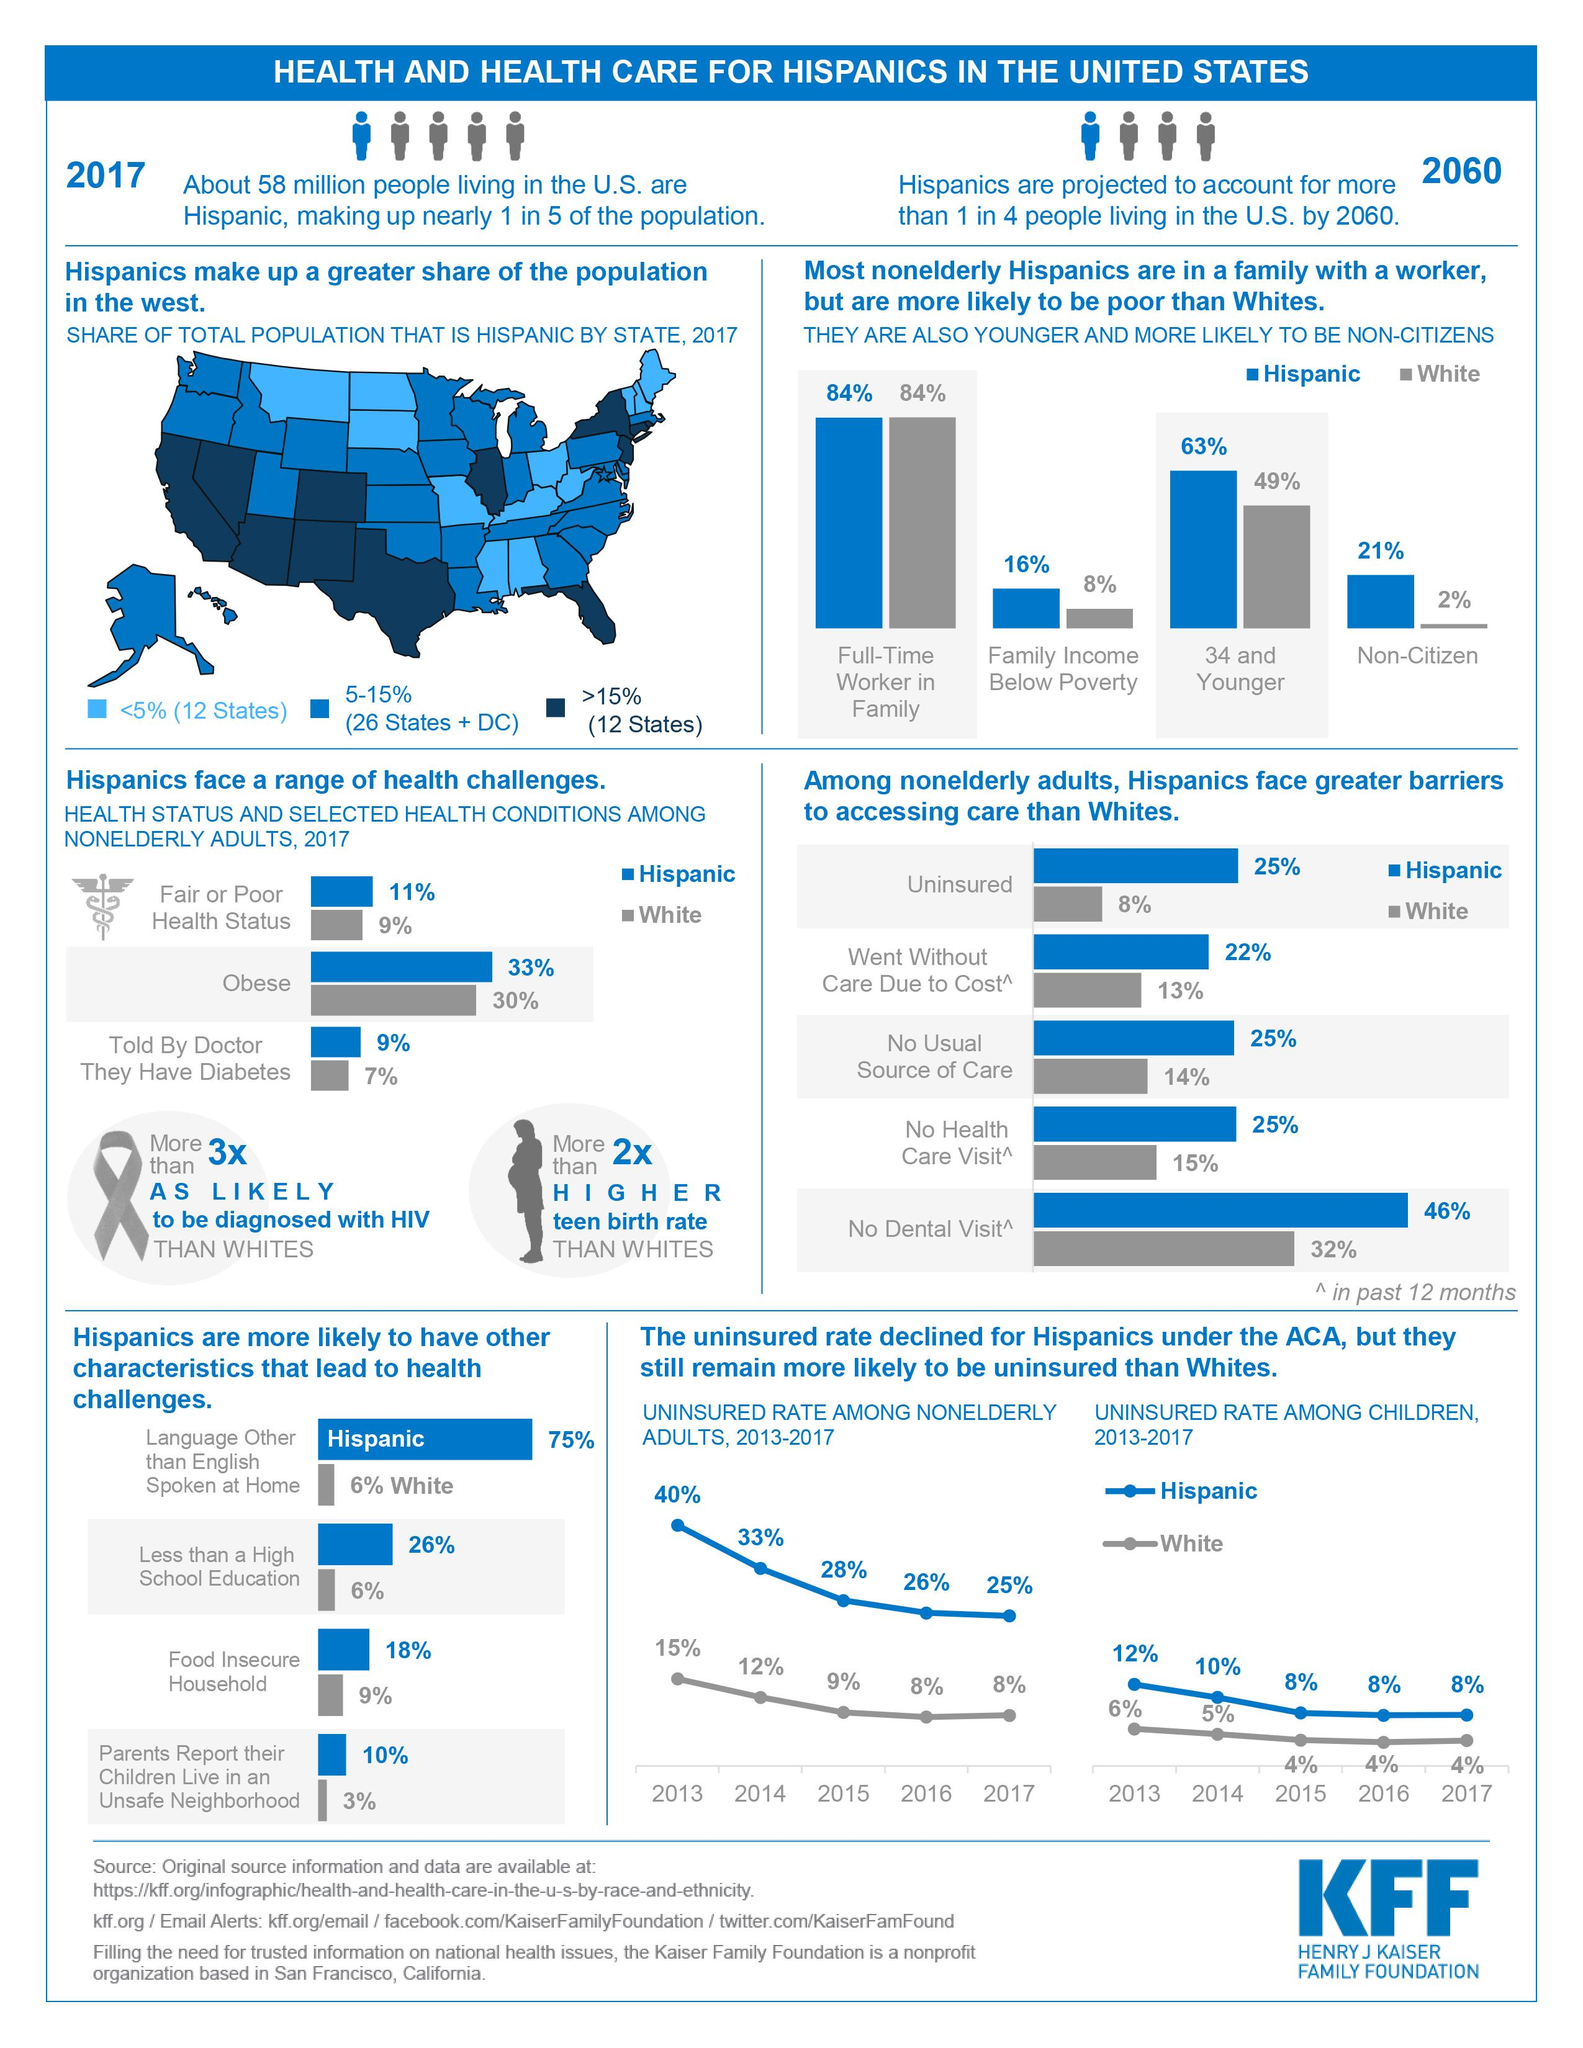Draw attention to some important aspects in this diagram. The source of the infographic is the Henry J Kaiser Family Foundation. According to data, 63% of Hispanics are in the age range of 34 and younger. According to recent data, 33% of the Hispanic population is obese. According to the latest data available in 2017, over half of all Hispanics lived in 5-15% of the states. 75% of Hispanic individuals speak a language other than English. 